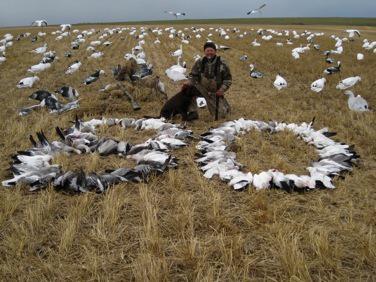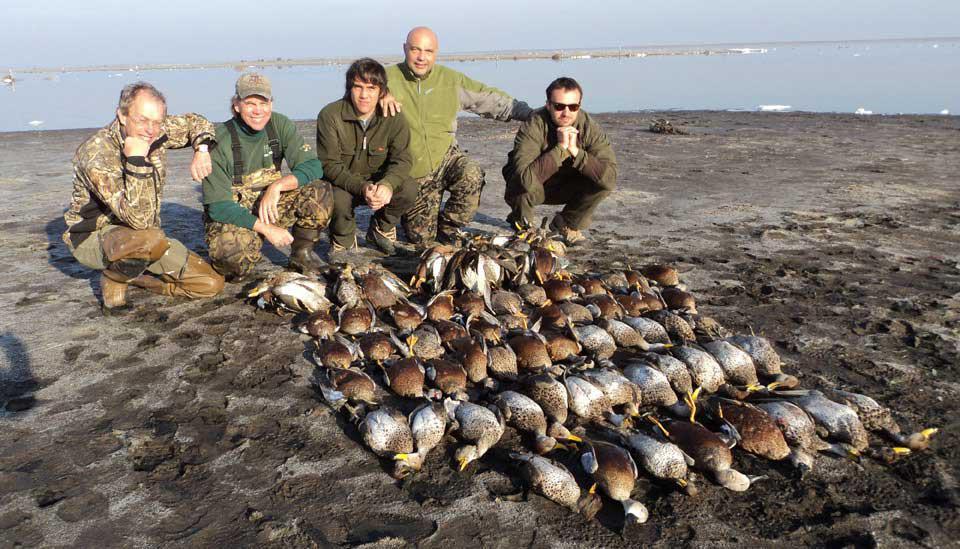The first image is the image on the left, the second image is the image on the right. For the images shown, is this caption "An image includes at least one hunter, dog and many dead birds." true? Answer yes or no. Yes. 